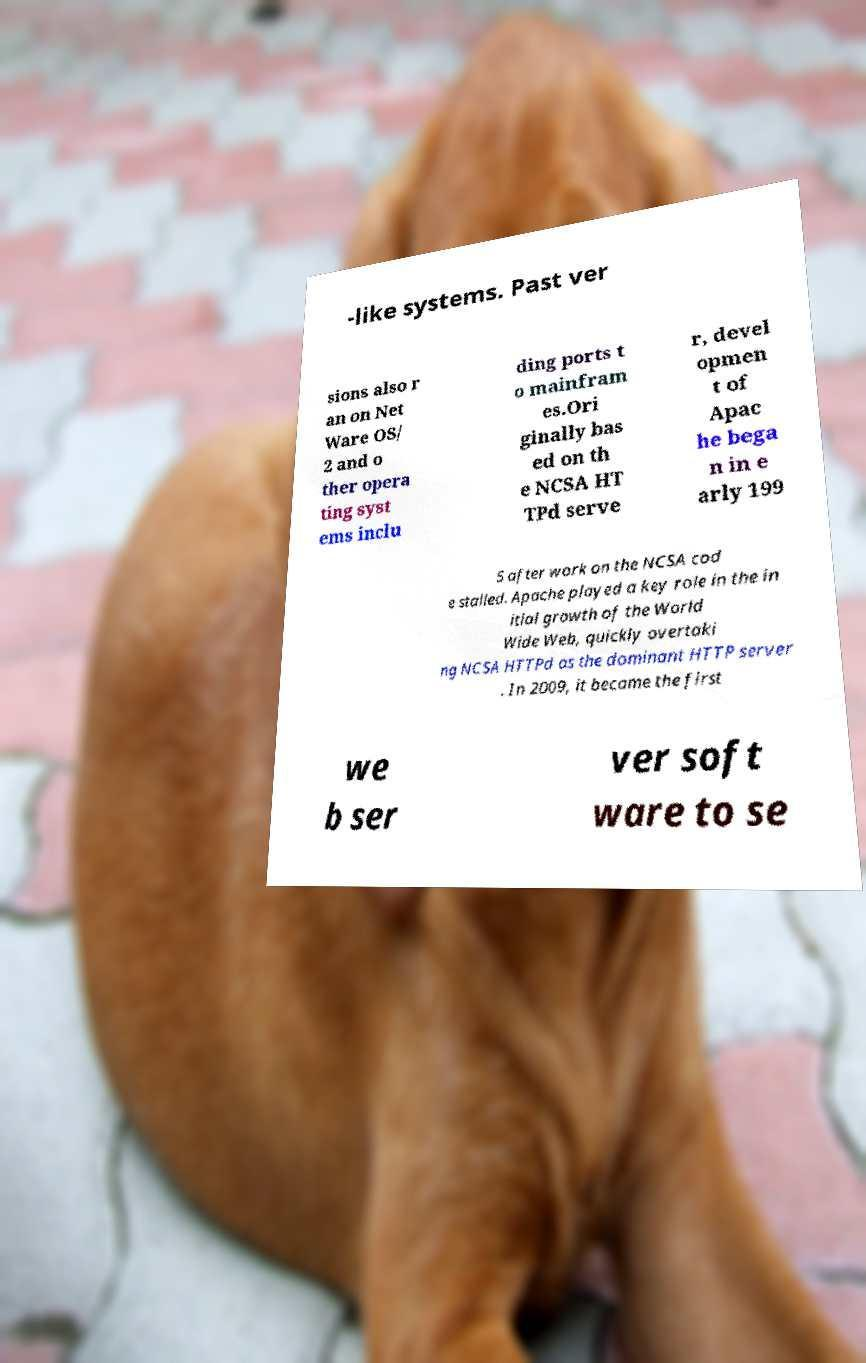I need the written content from this picture converted into text. Can you do that? -like systems. Past ver sions also r an on Net Ware OS/ 2 and o ther opera ting syst ems inclu ding ports t o mainfram es.Ori ginally bas ed on th e NCSA HT TPd serve r, devel opmen t of Apac he bega n in e arly 199 5 after work on the NCSA cod e stalled. Apache played a key role in the in itial growth of the World Wide Web, quickly overtaki ng NCSA HTTPd as the dominant HTTP server . In 2009, it became the first we b ser ver soft ware to se 